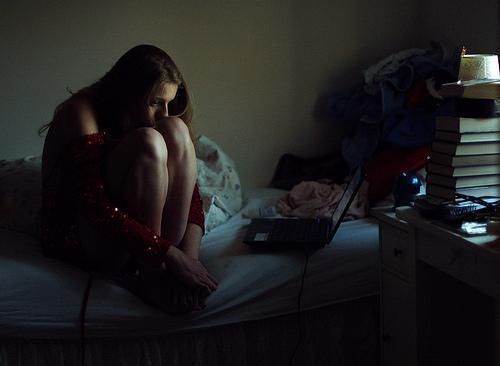How many people are pictured?
Give a very brief answer. 1. 